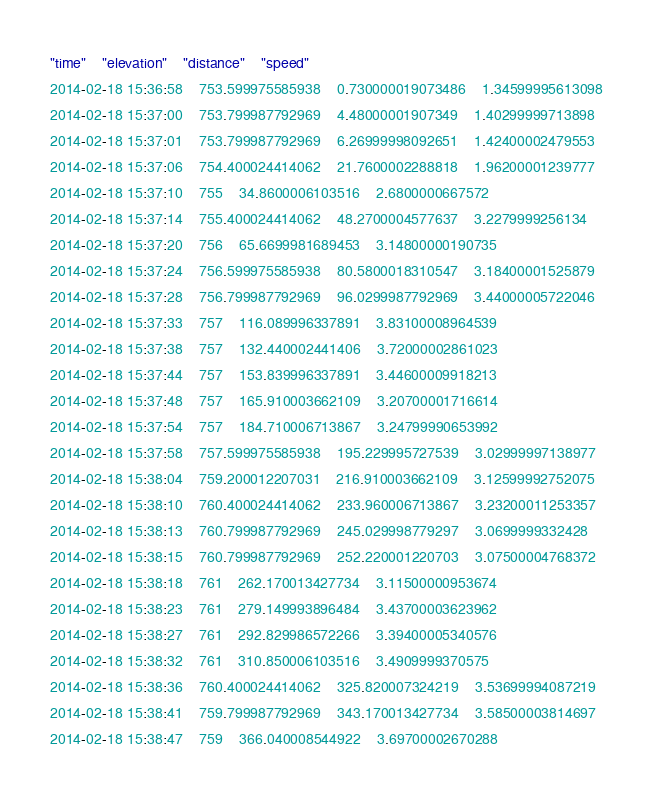Convert code to text. <code><loc_0><loc_0><loc_500><loc_500><_SQL_>"time"	"elevation"	"distance"	"speed"
2014-02-18 15:36:58	753.599975585938	0.730000019073486	1.34599995613098
2014-02-18 15:37:00	753.799987792969	4.48000001907349	1.40299999713898
2014-02-18 15:37:01	753.799987792969	6.26999998092651	1.42400002479553
2014-02-18 15:37:06	754.400024414062	21.7600002288818	1.96200001239777
2014-02-18 15:37:10	755	34.8600006103516	2.6800000667572
2014-02-18 15:37:14	755.400024414062	48.2700004577637	3.2279999256134
2014-02-18 15:37:20	756	65.6699981689453	3.14800000190735
2014-02-18 15:37:24	756.599975585938	80.5800018310547	3.18400001525879
2014-02-18 15:37:28	756.799987792969	96.0299987792969	3.44000005722046
2014-02-18 15:37:33	757	116.089996337891	3.83100008964539
2014-02-18 15:37:38	757	132.440002441406	3.72000002861023
2014-02-18 15:37:44	757	153.839996337891	3.44600009918213
2014-02-18 15:37:48	757	165.910003662109	3.20700001716614
2014-02-18 15:37:54	757	184.710006713867	3.24799990653992
2014-02-18 15:37:58	757.599975585938	195.229995727539	3.02999997138977
2014-02-18 15:38:04	759.200012207031	216.910003662109	3.12599992752075
2014-02-18 15:38:10	760.400024414062	233.960006713867	3.23200011253357
2014-02-18 15:38:13	760.799987792969	245.029998779297	3.0699999332428
2014-02-18 15:38:15	760.799987792969	252.220001220703	3.07500004768372
2014-02-18 15:38:18	761	262.170013427734	3.11500000953674
2014-02-18 15:38:23	761	279.149993896484	3.43700003623962
2014-02-18 15:38:27	761	292.829986572266	3.39400005340576
2014-02-18 15:38:32	761	310.850006103516	3.4909999370575
2014-02-18 15:38:36	760.400024414062	325.820007324219	3.53699994087219
2014-02-18 15:38:41	759.799987792969	343.170013427734	3.58500003814697
2014-02-18 15:38:47	759	366.040008544922	3.69700002670288</code> 